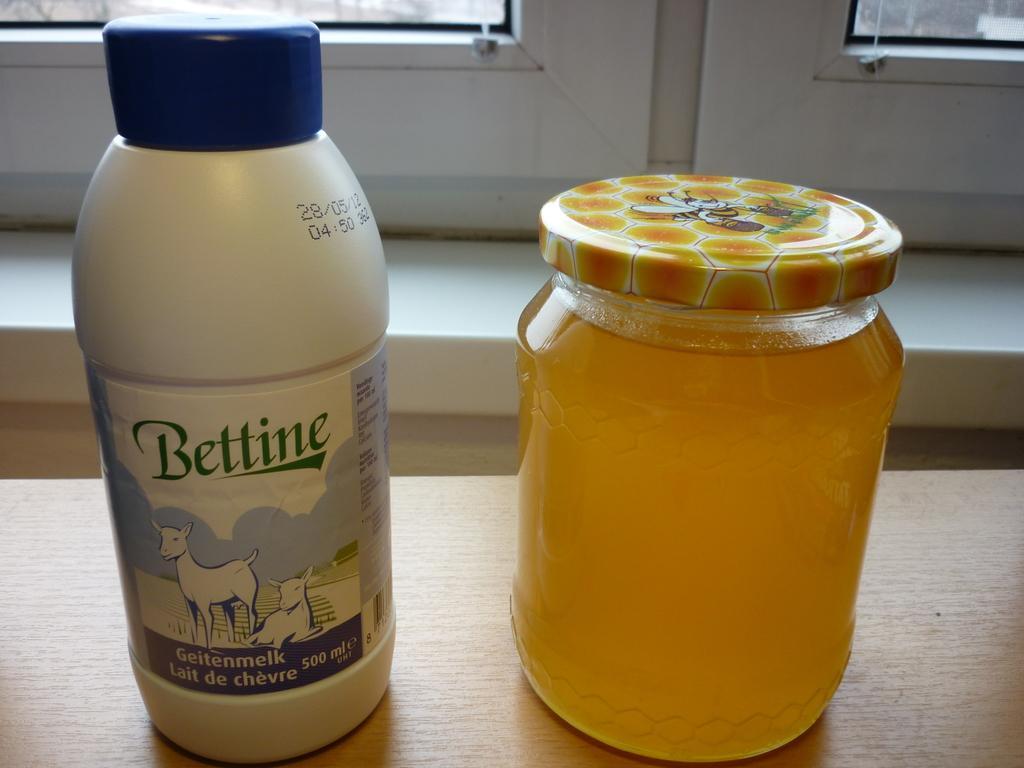Describe this image in one or two sentences. We can see bottle,jar on the table and we can see sticker on this bottle. On the background we can see glass window. 